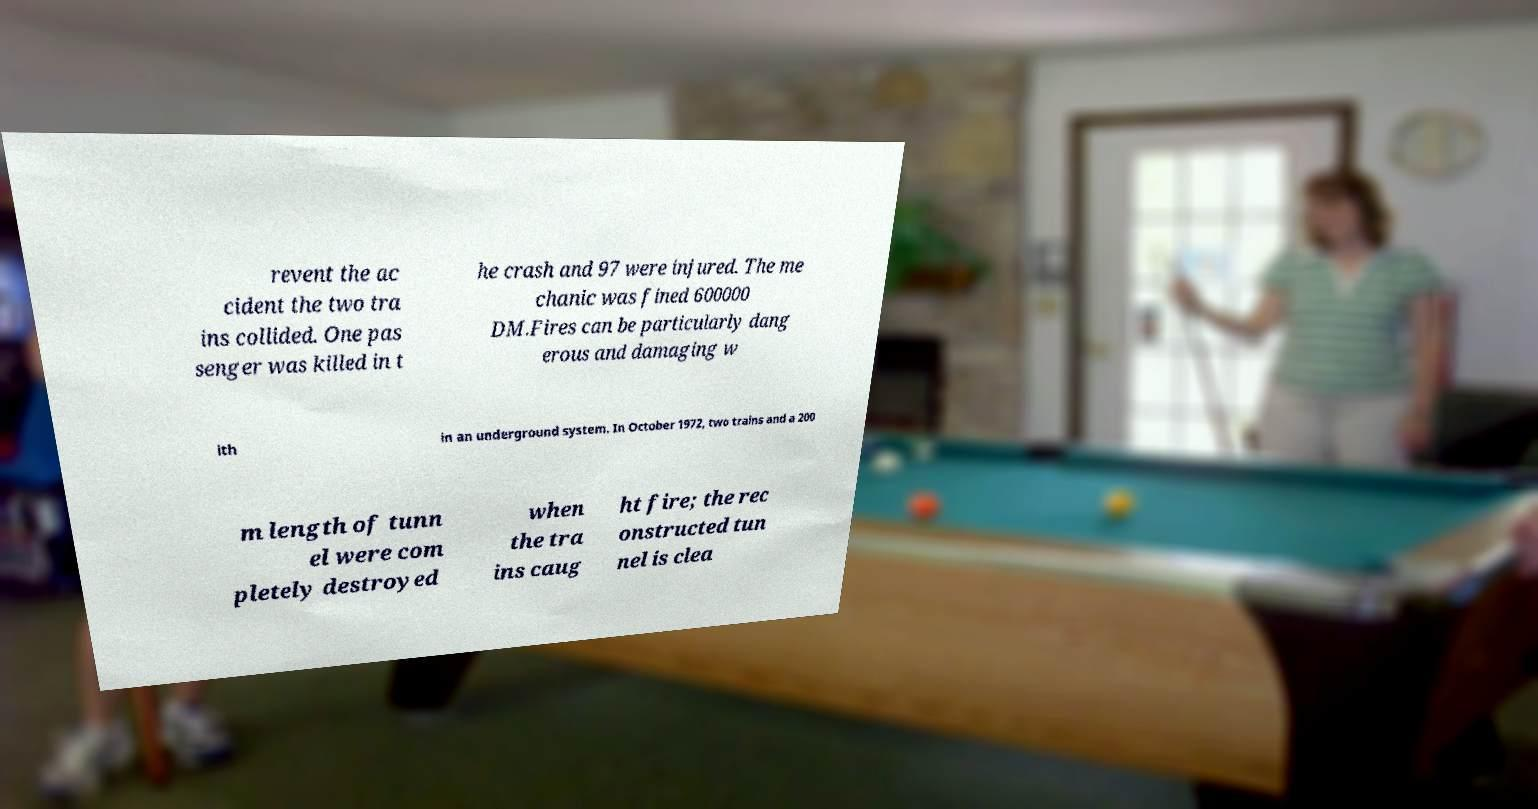There's text embedded in this image that I need extracted. Can you transcribe it verbatim? revent the ac cident the two tra ins collided. One pas senger was killed in t he crash and 97 were injured. The me chanic was fined 600000 DM.Fires can be particularly dang erous and damaging w ith in an underground system. In October 1972, two trains and a 200 m length of tunn el were com pletely destroyed when the tra ins caug ht fire; the rec onstructed tun nel is clea 